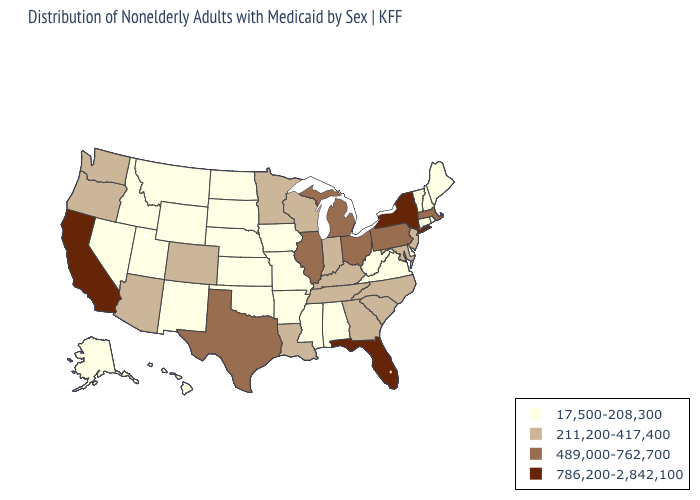Which states have the lowest value in the Northeast?
Concise answer only. Connecticut, Maine, New Hampshire, Rhode Island, Vermont. What is the value of Maryland?
Short answer required. 211,200-417,400. Name the states that have a value in the range 489,000-762,700?
Write a very short answer. Illinois, Massachusetts, Michigan, Ohio, Pennsylvania, Texas. What is the lowest value in states that border Rhode Island?
Be succinct. 17,500-208,300. Among the states that border Missouri , does Kansas have the lowest value?
Short answer required. Yes. Name the states that have a value in the range 786,200-2,842,100?
Keep it brief. California, Florida, New York. What is the highest value in states that border Alabama?
Quick response, please. 786,200-2,842,100. What is the value of Massachusetts?
Keep it brief. 489,000-762,700. Among the states that border Louisiana , does Texas have the lowest value?
Give a very brief answer. No. Does Florida have the same value as Pennsylvania?
Write a very short answer. No. Does the map have missing data?
Concise answer only. No. What is the value of South Dakota?
Be succinct. 17,500-208,300. What is the value of Tennessee?
Short answer required. 211,200-417,400. Does the first symbol in the legend represent the smallest category?
Write a very short answer. Yes. Among the states that border Wyoming , does Idaho have the lowest value?
Short answer required. Yes. 